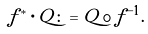<formula> <loc_0><loc_0><loc_500><loc_500>f ^ { * } \cdot Q \colon = Q \circ \tilde { f } ^ { - 1 } .</formula> 